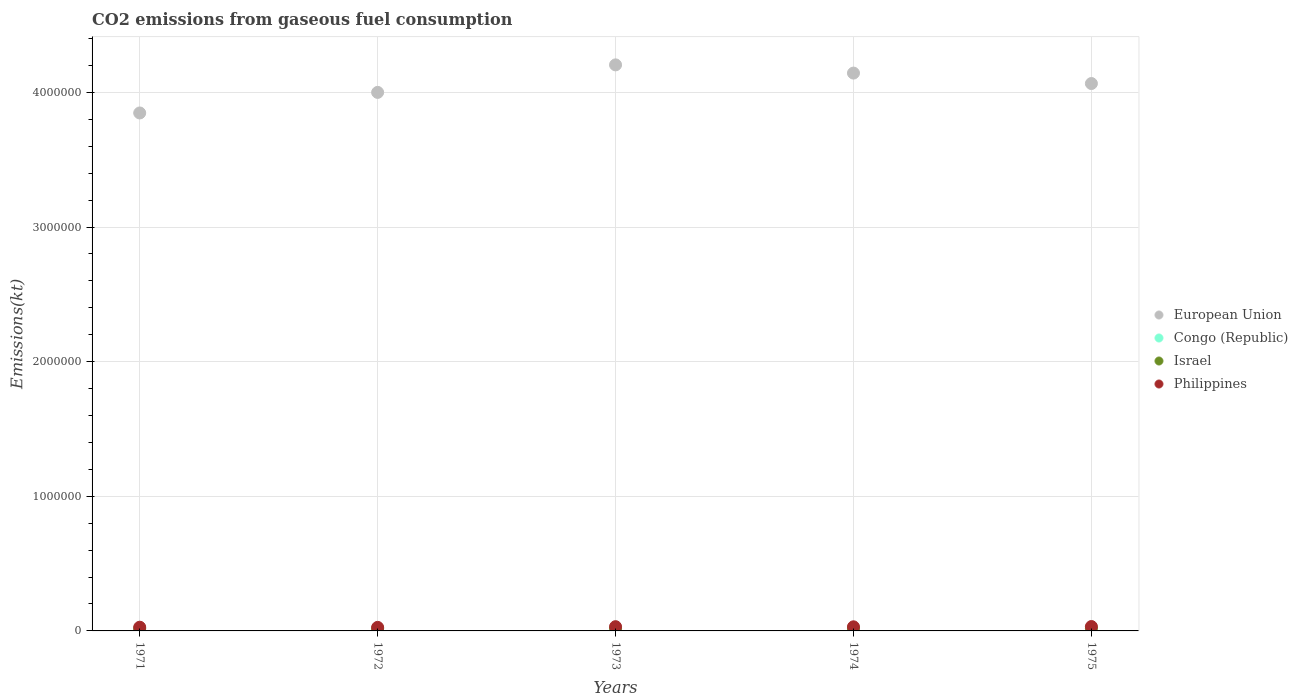Is the number of dotlines equal to the number of legend labels?
Your answer should be compact. Yes. What is the amount of CO2 emitted in Israel in 1974?
Your answer should be compact. 1.94e+04. Across all years, what is the maximum amount of CO2 emitted in European Union?
Offer a very short reply. 4.20e+06. Across all years, what is the minimum amount of CO2 emitted in European Union?
Ensure brevity in your answer.  3.85e+06. In which year was the amount of CO2 emitted in Congo (Republic) maximum?
Ensure brevity in your answer.  1974. In which year was the amount of CO2 emitted in European Union minimum?
Make the answer very short. 1971. What is the total amount of CO2 emitted in European Union in the graph?
Offer a very short reply. 2.03e+07. What is the difference between the amount of CO2 emitted in Philippines in 1972 and that in 1975?
Your response must be concise. -6083.55. What is the difference between the amount of CO2 emitted in Philippines in 1975 and the amount of CO2 emitted in Congo (Republic) in 1974?
Make the answer very short. 3.09e+04. What is the average amount of CO2 emitted in Israel per year?
Give a very brief answer. 1.83e+04. In the year 1974, what is the difference between the amount of CO2 emitted in Israel and amount of CO2 emitted in Congo (Republic)?
Your answer should be compact. 1.78e+04. What is the ratio of the amount of CO2 emitted in European Union in 1971 to that in 1974?
Offer a terse response. 0.93. What is the difference between the highest and the second highest amount of CO2 emitted in Israel?
Keep it short and to the point. 201.69. What is the difference between the highest and the lowest amount of CO2 emitted in Israel?
Your answer should be compact. 3399.31. In how many years, is the amount of CO2 emitted in European Union greater than the average amount of CO2 emitted in European Union taken over all years?
Keep it short and to the point. 3. Is the sum of the amount of CO2 emitted in Philippines in 1972 and 1974 greater than the maximum amount of CO2 emitted in Israel across all years?
Your response must be concise. Yes. Is it the case that in every year, the sum of the amount of CO2 emitted in Philippines and amount of CO2 emitted in Congo (Republic)  is greater than the sum of amount of CO2 emitted in European Union and amount of CO2 emitted in Israel?
Ensure brevity in your answer.  Yes. Is it the case that in every year, the sum of the amount of CO2 emitted in European Union and amount of CO2 emitted in Congo (Republic)  is greater than the amount of CO2 emitted in Israel?
Provide a succinct answer. Yes. Is the amount of CO2 emitted in Philippines strictly greater than the amount of CO2 emitted in Israel over the years?
Provide a short and direct response. Yes. Does the graph contain any zero values?
Ensure brevity in your answer.  No. Does the graph contain grids?
Give a very brief answer. Yes. How many legend labels are there?
Offer a very short reply. 4. How are the legend labels stacked?
Make the answer very short. Vertical. What is the title of the graph?
Offer a terse response. CO2 emissions from gaseous fuel consumption. Does "Virgin Islands" appear as one of the legend labels in the graph?
Offer a terse response. No. What is the label or title of the X-axis?
Keep it short and to the point. Years. What is the label or title of the Y-axis?
Your answer should be compact. Emissions(kt). What is the Emissions(kt) in European Union in 1971?
Provide a succinct answer. 3.85e+06. What is the Emissions(kt) in Congo (Republic) in 1971?
Provide a short and direct response. 685.73. What is the Emissions(kt) of Israel in 1971?
Offer a terse response. 1.62e+04. What is the Emissions(kt) of Philippines in 1971?
Offer a terse response. 2.76e+04. What is the Emissions(kt) of European Union in 1972?
Make the answer very short. 4.00e+06. What is the Emissions(kt) of Congo (Republic) in 1972?
Offer a terse response. 663.73. What is the Emissions(kt) in Israel in 1972?
Your answer should be very brief. 1.69e+04. What is the Emissions(kt) in Philippines in 1972?
Keep it short and to the point. 2.64e+04. What is the Emissions(kt) of European Union in 1973?
Your answer should be very brief. 4.20e+06. What is the Emissions(kt) in Congo (Republic) in 1973?
Ensure brevity in your answer.  1221.11. What is the Emissions(kt) in Israel in 1973?
Offer a very short reply. 1.93e+04. What is the Emissions(kt) in Philippines in 1973?
Make the answer very short. 3.15e+04. What is the Emissions(kt) of European Union in 1974?
Give a very brief answer. 4.14e+06. What is the Emissions(kt) in Congo (Republic) in 1974?
Provide a short and direct response. 1624.48. What is the Emissions(kt) in Israel in 1974?
Offer a terse response. 1.94e+04. What is the Emissions(kt) in Philippines in 1974?
Ensure brevity in your answer.  3.05e+04. What is the Emissions(kt) of European Union in 1975?
Your answer should be compact. 4.07e+06. What is the Emissions(kt) in Congo (Republic) in 1975?
Your response must be concise. 1100.1. What is the Emissions(kt) in Israel in 1975?
Give a very brief answer. 1.96e+04. What is the Emissions(kt) of Philippines in 1975?
Make the answer very short. 3.25e+04. Across all years, what is the maximum Emissions(kt) of European Union?
Make the answer very short. 4.20e+06. Across all years, what is the maximum Emissions(kt) of Congo (Republic)?
Give a very brief answer. 1624.48. Across all years, what is the maximum Emissions(kt) in Israel?
Give a very brief answer. 1.96e+04. Across all years, what is the maximum Emissions(kt) in Philippines?
Your answer should be compact. 3.25e+04. Across all years, what is the minimum Emissions(kt) of European Union?
Provide a succinct answer. 3.85e+06. Across all years, what is the minimum Emissions(kt) in Congo (Republic)?
Your answer should be compact. 663.73. Across all years, what is the minimum Emissions(kt) in Israel?
Your response must be concise. 1.62e+04. Across all years, what is the minimum Emissions(kt) in Philippines?
Your answer should be very brief. 2.64e+04. What is the total Emissions(kt) of European Union in the graph?
Provide a short and direct response. 2.03e+07. What is the total Emissions(kt) of Congo (Republic) in the graph?
Your answer should be compact. 5295.15. What is the total Emissions(kt) in Israel in the graph?
Keep it short and to the point. 9.16e+04. What is the total Emissions(kt) in Philippines in the graph?
Offer a very short reply. 1.49e+05. What is the difference between the Emissions(kt) in European Union in 1971 and that in 1972?
Provide a short and direct response. -1.53e+05. What is the difference between the Emissions(kt) of Congo (Republic) in 1971 and that in 1972?
Offer a very short reply. 22. What is the difference between the Emissions(kt) of Israel in 1971 and that in 1972?
Your response must be concise. -685.73. What is the difference between the Emissions(kt) in Philippines in 1971 and that in 1972?
Offer a terse response. 1144.1. What is the difference between the Emissions(kt) in European Union in 1971 and that in 1973?
Your answer should be very brief. -3.57e+05. What is the difference between the Emissions(kt) in Congo (Republic) in 1971 and that in 1973?
Make the answer very short. -535.38. What is the difference between the Emissions(kt) of Israel in 1971 and that in 1973?
Provide a short and direct response. -3061.95. What is the difference between the Emissions(kt) of Philippines in 1971 and that in 1973?
Provide a short and direct response. -3956.69. What is the difference between the Emissions(kt) in European Union in 1971 and that in 1974?
Your answer should be very brief. -2.96e+05. What is the difference between the Emissions(kt) of Congo (Republic) in 1971 and that in 1974?
Provide a succinct answer. -938.75. What is the difference between the Emissions(kt) in Israel in 1971 and that in 1974?
Your answer should be very brief. -3197.62. What is the difference between the Emissions(kt) in Philippines in 1971 and that in 1974?
Keep it short and to the point. -2944.6. What is the difference between the Emissions(kt) of European Union in 1971 and that in 1975?
Provide a short and direct response. -2.19e+05. What is the difference between the Emissions(kt) of Congo (Republic) in 1971 and that in 1975?
Your answer should be compact. -414.37. What is the difference between the Emissions(kt) in Israel in 1971 and that in 1975?
Your response must be concise. -3399.31. What is the difference between the Emissions(kt) of Philippines in 1971 and that in 1975?
Provide a short and direct response. -4939.45. What is the difference between the Emissions(kt) of European Union in 1972 and that in 1973?
Your answer should be compact. -2.04e+05. What is the difference between the Emissions(kt) in Congo (Republic) in 1972 and that in 1973?
Keep it short and to the point. -557.38. What is the difference between the Emissions(kt) of Israel in 1972 and that in 1973?
Give a very brief answer. -2376.22. What is the difference between the Emissions(kt) of Philippines in 1972 and that in 1973?
Your answer should be very brief. -5100.8. What is the difference between the Emissions(kt) of European Union in 1972 and that in 1974?
Provide a succinct answer. -1.43e+05. What is the difference between the Emissions(kt) of Congo (Republic) in 1972 and that in 1974?
Make the answer very short. -960.75. What is the difference between the Emissions(kt) of Israel in 1972 and that in 1974?
Ensure brevity in your answer.  -2511.89. What is the difference between the Emissions(kt) of Philippines in 1972 and that in 1974?
Provide a short and direct response. -4088.7. What is the difference between the Emissions(kt) in European Union in 1972 and that in 1975?
Make the answer very short. -6.58e+04. What is the difference between the Emissions(kt) of Congo (Republic) in 1972 and that in 1975?
Keep it short and to the point. -436.37. What is the difference between the Emissions(kt) of Israel in 1972 and that in 1975?
Offer a very short reply. -2713.58. What is the difference between the Emissions(kt) in Philippines in 1972 and that in 1975?
Your answer should be compact. -6083.55. What is the difference between the Emissions(kt) in European Union in 1973 and that in 1974?
Your response must be concise. 6.10e+04. What is the difference between the Emissions(kt) in Congo (Republic) in 1973 and that in 1974?
Your answer should be very brief. -403.37. What is the difference between the Emissions(kt) of Israel in 1973 and that in 1974?
Ensure brevity in your answer.  -135.68. What is the difference between the Emissions(kt) of Philippines in 1973 and that in 1974?
Your response must be concise. 1012.09. What is the difference between the Emissions(kt) of European Union in 1973 and that in 1975?
Your answer should be compact. 1.39e+05. What is the difference between the Emissions(kt) in Congo (Republic) in 1973 and that in 1975?
Provide a short and direct response. 121.01. What is the difference between the Emissions(kt) of Israel in 1973 and that in 1975?
Make the answer very short. -337.36. What is the difference between the Emissions(kt) of Philippines in 1973 and that in 1975?
Offer a very short reply. -982.76. What is the difference between the Emissions(kt) in European Union in 1974 and that in 1975?
Keep it short and to the point. 7.76e+04. What is the difference between the Emissions(kt) in Congo (Republic) in 1974 and that in 1975?
Ensure brevity in your answer.  524.38. What is the difference between the Emissions(kt) of Israel in 1974 and that in 1975?
Your answer should be compact. -201.69. What is the difference between the Emissions(kt) of Philippines in 1974 and that in 1975?
Give a very brief answer. -1994.85. What is the difference between the Emissions(kt) in European Union in 1971 and the Emissions(kt) in Congo (Republic) in 1972?
Offer a terse response. 3.85e+06. What is the difference between the Emissions(kt) in European Union in 1971 and the Emissions(kt) in Israel in 1972?
Make the answer very short. 3.83e+06. What is the difference between the Emissions(kt) in European Union in 1971 and the Emissions(kt) in Philippines in 1972?
Provide a short and direct response. 3.82e+06. What is the difference between the Emissions(kt) in Congo (Republic) in 1971 and the Emissions(kt) in Israel in 1972?
Keep it short and to the point. -1.62e+04. What is the difference between the Emissions(kt) of Congo (Republic) in 1971 and the Emissions(kt) of Philippines in 1972?
Provide a short and direct response. -2.58e+04. What is the difference between the Emissions(kt) of Israel in 1971 and the Emissions(kt) of Philippines in 1972?
Give a very brief answer. -1.02e+04. What is the difference between the Emissions(kt) in European Union in 1971 and the Emissions(kt) in Congo (Republic) in 1973?
Your response must be concise. 3.85e+06. What is the difference between the Emissions(kt) of European Union in 1971 and the Emissions(kt) of Israel in 1973?
Make the answer very short. 3.83e+06. What is the difference between the Emissions(kt) of European Union in 1971 and the Emissions(kt) of Philippines in 1973?
Ensure brevity in your answer.  3.82e+06. What is the difference between the Emissions(kt) of Congo (Republic) in 1971 and the Emissions(kt) of Israel in 1973?
Provide a succinct answer. -1.86e+04. What is the difference between the Emissions(kt) of Congo (Republic) in 1971 and the Emissions(kt) of Philippines in 1973?
Your answer should be very brief. -3.09e+04. What is the difference between the Emissions(kt) of Israel in 1971 and the Emissions(kt) of Philippines in 1973?
Provide a short and direct response. -1.53e+04. What is the difference between the Emissions(kt) in European Union in 1971 and the Emissions(kt) in Congo (Republic) in 1974?
Your answer should be compact. 3.85e+06. What is the difference between the Emissions(kt) in European Union in 1971 and the Emissions(kt) in Israel in 1974?
Your answer should be very brief. 3.83e+06. What is the difference between the Emissions(kt) in European Union in 1971 and the Emissions(kt) in Philippines in 1974?
Your response must be concise. 3.82e+06. What is the difference between the Emissions(kt) of Congo (Republic) in 1971 and the Emissions(kt) of Israel in 1974?
Make the answer very short. -1.88e+04. What is the difference between the Emissions(kt) in Congo (Republic) in 1971 and the Emissions(kt) in Philippines in 1974?
Provide a short and direct response. -2.98e+04. What is the difference between the Emissions(kt) in Israel in 1971 and the Emissions(kt) in Philippines in 1974?
Keep it short and to the point. -1.43e+04. What is the difference between the Emissions(kt) in European Union in 1971 and the Emissions(kt) in Congo (Republic) in 1975?
Offer a very short reply. 3.85e+06. What is the difference between the Emissions(kt) of European Union in 1971 and the Emissions(kt) of Israel in 1975?
Ensure brevity in your answer.  3.83e+06. What is the difference between the Emissions(kt) in European Union in 1971 and the Emissions(kt) in Philippines in 1975?
Your response must be concise. 3.81e+06. What is the difference between the Emissions(kt) of Congo (Republic) in 1971 and the Emissions(kt) of Israel in 1975?
Your response must be concise. -1.90e+04. What is the difference between the Emissions(kt) of Congo (Republic) in 1971 and the Emissions(kt) of Philippines in 1975?
Your answer should be compact. -3.18e+04. What is the difference between the Emissions(kt) in Israel in 1971 and the Emissions(kt) in Philippines in 1975?
Your response must be concise. -1.63e+04. What is the difference between the Emissions(kt) of European Union in 1972 and the Emissions(kt) of Congo (Republic) in 1973?
Provide a short and direct response. 4.00e+06. What is the difference between the Emissions(kt) of European Union in 1972 and the Emissions(kt) of Israel in 1973?
Your answer should be compact. 3.98e+06. What is the difference between the Emissions(kt) in European Union in 1972 and the Emissions(kt) in Philippines in 1973?
Make the answer very short. 3.97e+06. What is the difference between the Emissions(kt) in Congo (Republic) in 1972 and the Emissions(kt) in Israel in 1973?
Provide a short and direct response. -1.86e+04. What is the difference between the Emissions(kt) in Congo (Republic) in 1972 and the Emissions(kt) in Philippines in 1973?
Ensure brevity in your answer.  -3.09e+04. What is the difference between the Emissions(kt) of Israel in 1972 and the Emissions(kt) of Philippines in 1973?
Offer a terse response. -1.46e+04. What is the difference between the Emissions(kt) in European Union in 1972 and the Emissions(kt) in Congo (Republic) in 1974?
Offer a terse response. 4.00e+06. What is the difference between the Emissions(kt) in European Union in 1972 and the Emissions(kt) in Israel in 1974?
Keep it short and to the point. 3.98e+06. What is the difference between the Emissions(kt) in European Union in 1972 and the Emissions(kt) in Philippines in 1974?
Provide a succinct answer. 3.97e+06. What is the difference between the Emissions(kt) in Congo (Republic) in 1972 and the Emissions(kt) in Israel in 1974?
Offer a terse response. -1.88e+04. What is the difference between the Emissions(kt) of Congo (Republic) in 1972 and the Emissions(kt) of Philippines in 1974?
Make the answer very short. -2.99e+04. What is the difference between the Emissions(kt) in Israel in 1972 and the Emissions(kt) in Philippines in 1974?
Your response must be concise. -1.36e+04. What is the difference between the Emissions(kt) of European Union in 1972 and the Emissions(kt) of Congo (Republic) in 1975?
Offer a terse response. 4.00e+06. What is the difference between the Emissions(kt) in European Union in 1972 and the Emissions(kt) in Israel in 1975?
Provide a short and direct response. 3.98e+06. What is the difference between the Emissions(kt) in European Union in 1972 and the Emissions(kt) in Philippines in 1975?
Provide a short and direct response. 3.97e+06. What is the difference between the Emissions(kt) of Congo (Republic) in 1972 and the Emissions(kt) of Israel in 1975?
Your response must be concise. -1.90e+04. What is the difference between the Emissions(kt) of Congo (Republic) in 1972 and the Emissions(kt) of Philippines in 1975?
Make the answer very short. -3.19e+04. What is the difference between the Emissions(kt) in Israel in 1972 and the Emissions(kt) in Philippines in 1975?
Offer a terse response. -1.56e+04. What is the difference between the Emissions(kt) in European Union in 1973 and the Emissions(kt) in Congo (Republic) in 1974?
Keep it short and to the point. 4.20e+06. What is the difference between the Emissions(kt) of European Union in 1973 and the Emissions(kt) of Israel in 1974?
Your answer should be very brief. 4.18e+06. What is the difference between the Emissions(kt) in European Union in 1973 and the Emissions(kt) in Philippines in 1974?
Your answer should be very brief. 4.17e+06. What is the difference between the Emissions(kt) in Congo (Republic) in 1973 and the Emissions(kt) in Israel in 1974?
Provide a succinct answer. -1.82e+04. What is the difference between the Emissions(kt) in Congo (Republic) in 1973 and the Emissions(kt) in Philippines in 1974?
Provide a succinct answer. -2.93e+04. What is the difference between the Emissions(kt) of Israel in 1973 and the Emissions(kt) of Philippines in 1974?
Your answer should be compact. -1.12e+04. What is the difference between the Emissions(kt) in European Union in 1973 and the Emissions(kt) in Congo (Republic) in 1975?
Your response must be concise. 4.20e+06. What is the difference between the Emissions(kt) of European Union in 1973 and the Emissions(kt) of Israel in 1975?
Offer a very short reply. 4.18e+06. What is the difference between the Emissions(kt) in European Union in 1973 and the Emissions(kt) in Philippines in 1975?
Give a very brief answer. 4.17e+06. What is the difference between the Emissions(kt) in Congo (Republic) in 1973 and the Emissions(kt) in Israel in 1975?
Your answer should be very brief. -1.84e+04. What is the difference between the Emissions(kt) of Congo (Republic) in 1973 and the Emissions(kt) of Philippines in 1975?
Keep it short and to the point. -3.13e+04. What is the difference between the Emissions(kt) in Israel in 1973 and the Emissions(kt) in Philippines in 1975?
Your answer should be compact. -1.32e+04. What is the difference between the Emissions(kt) of European Union in 1974 and the Emissions(kt) of Congo (Republic) in 1975?
Offer a terse response. 4.14e+06. What is the difference between the Emissions(kt) of European Union in 1974 and the Emissions(kt) of Israel in 1975?
Offer a terse response. 4.12e+06. What is the difference between the Emissions(kt) in European Union in 1974 and the Emissions(kt) in Philippines in 1975?
Offer a terse response. 4.11e+06. What is the difference between the Emissions(kt) in Congo (Republic) in 1974 and the Emissions(kt) in Israel in 1975?
Ensure brevity in your answer.  -1.80e+04. What is the difference between the Emissions(kt) in Congo (Republic) in 1974 and the Emissions(kt) in Philippines in 1975?
Make the answer very short. -3.09e+04. What is the difference between the Emissions(kt) of Israel in 1974 and the Emissions(kt) of Philippines in 1975?
Provide a succinct answer. -1.31e+04. What is the average Emissions(kt) of European Union per year?
Make the answer very short. 4.05e+06. What is the average Emissions(kt) of Congo (Republic) per year?
Offer a terse response. 1059.03. What is the average Emissions(kt) in Israel per year?
Your response must be concise. 1.83e+04. What is the average Emissions(kt) of Philippines per year?
Your answer should be very brief. 2.97e+04. In the year 1971, what is the difference between the Emissions(kt) in European Union and Emissions(kt) in Congo (Republic)?
Offer a very short reply. 3.85e+06. In the year 1971, what is the difference between the Emissions(kt) in European Union and Emissions(kt) in Israel?
Make the answer very short. 3.83e+06. In the year 1971, what is the difference between the Emissions(kt) in European Union and Emissions(kt) in Philippines?
Make the answer very short. 3.82e+06. In the year 1971, what is the difference between the Emissions(kt) in Congo (Republic) and Emissions(kt) in Israel?
Keep it short and to the point. -1.56e+04. In the year 1971, what is the difference between the Emissions(kt) in Congo (Republic) and Emissions(kt) in Philippines?
Provide a short and direct response. -2.69e+04. In the year 1971, what is the difference between the Emissions(kt) of Israel and Emissions(kt) of Philippines?
Your response must be concise. -1.13e+04. In the year 1972, what is the difference between the Emissions(kt) in European Union and Emissions(kt) in Congo (Republic)?
Your answer should be very brief. 4.00e+06. In the year 1972, what is the difference between the Emissions(kt) in European Union and Emissions(kt) in Israel?
Your answer should be very brief. 3.98e+06. In the year 1972, what is the difference between the Emissions(kt) in European Union and Emissions(kt) in Philippines?
Offer a terse response. 3.97e+06. In the year 1972, what is the difference between the Emissions(kt) in Congo (Republic) and Emissions(kt) in Israel?
Make the answer very short. -1.63e+04. In the year 1972, what is the difference between the Emissions(kt) in Congo (Republic) and Emissions(kt) in Philippines?
Offer a very short reply. -2.58e+04. In the year 1972, what is the difference between the Emissions(kt) of Israel and Emissions(kt) of Philippines?
Make the answer very short. -9508.53. In the year 1973, what is the difference between the Emissions(kt) of European Union and Emissions(kt) of Congo (Republic)?
Give a very brief answer. 4.20e+06. In the year 1973, what is the difference between the Emissions(kt) in European Union and Emissions(kt) in Israel?
Give a very brief answer. 4.19e+06. In the year 1973, what is the difference between the Emissions(kt) of European Union and Emissions(kt) of Philippines?
Your response must be concise. 4.17e+06. In the year 1973, what is the difference between the Emissions(kt) in Congo (Republic) and Emissions(kt) in Israel?
Provide a succinct answer. -1.81e+04. In the year 1973, what is the difference between the Emissions(kt) of Congo (Republic) and Emissions(kt) of Philippines?
Give a very brief answer. -3.03e+04. In the year 1973, what is the difference between the Emissions(kt) of Israel and Emissions(kt) of Philippines?
Offer a terse response. -1.22e+04. In the year 1974, what is the difference between the Emissions(kt) in European Union and Emissions(kt) in Congo (Republic)?
Offer a very short reply. 4.14e+06. In the year 1974, what is the difference between the Emissions(kt) of European Union and Emissions(kt) of Israel?
Offer a very short reply. 4.12e+06. In the year 1974, what is the difference between the Emissions(kt) of European Union and Emissions(kt) of Philippines?
Offer a very short reply. 4.11e+06. In the year 1974, what is the difference between the Emissions(kt) of Congo (Republic) and Emissions(kt) of Israel?
Your answer should be compact. -1.78e+04. In the year 1974, what is the difference between the Emissions(kt) in Congo (Republic) and Emissions(kt) in Philippines?
Give a very brief answer. -2.89e+04. In the year 1974, what is the difference between the Emissions(kt) in Israel and Emissions(kt) in Philippines?
Your answer should be compact. -1.11e+04. In the year 1975, what is the difference between the Emissions(kt) in European Union and Emissions(kt) in Congo (Republic)?
Your answer should be compact. 4.06e+06. In the year 1975, what is the difference between the Emissions(kt) of European Union and Emissions(kt) of Israel?
Give a very brief answer. 4.05e+06. In the year 1975, what is the difference between the Emissions(kt) in European Union and Emissions(kt) in Philippines?
Ensure brevity in your answer.  4.03e+06. In the year 1975, what is the difference between the Emissions(kt) in Congo (Republic) and Emissions(kt) in Israel?
Give a very brief answer. -1.85e+04. In the year 1975, what is the difference between the Emissions(kt) of Congo (Republic) and Emissions(kt) of Philippines?
Make the answer very short. -3.14e+04. In the year 1975, what is the difference between the Emissions(kt) in Israel and Emissions(kt) in Philippines?
Your answer should be compact. -1.29e+04. What is the ratio of the Emissions(kt) of European Union in 1971 to that in 1972?
Keep it short and to the point. 0.96. What is the ratio of the Emissions(kt) of Congo (Republic) in 1971 to that in 1972?
Your answer should be compact. 1.03. What is the ratio of the Emissions(kt) in Israel in 1971 to that in 1972?
Give a very brief answer. 0.96. What is the ratio of the Emissions(kt) of Philippines in 1971 to that in 1972?
Your answer should be compact. 1.04. What is the ratio of the Emissions(kt) of European Union in 1971 to that in 1973?
Offer a terse response. 0.92. What is the ratio of the Emissions(kt) of Congo (Republic) in 1971 to that in 1973?
Provide a succinct answer. 0.56. What is the ratio of the Emissions(kt) of Israel in 1971 to that in 1973?
Provide a succinct answer. 0.84. What is the ratio of the Emissions(kt) of Philippines in 1971 to that in 1973?
Give a very brief answer. 0.87. What is the ratio of the Emissions(kt) in European Union in 1971 to that in 1974?
Offer a terse response. 0.93. What is the ratio of the Emissions(kt) in Congo (Republic) in 1971 to that in 1974?
Your response must be concise. 0.42. What is the ratio of the Emissions(kt) of Israel in 1971 to that in 1974?
Offer a terse response. 0.84. What is the ratio of the Emissions(kt) of Philippines in 1971 to that in 1974?
Offer a terse response. 0.9. What is the ratio of the Emissions(kt) of European Union in 1971 to that in 1975?
Your answer should be compact. 0.95. What is the ratio of the Emissions(kt) of Congo (Republic) in 1971 to that in 1975?
Ensure brevity in your answer.  0.62. What is the ratio of the Emissions(kt) in Israel in 1971 to that in 1975?
Provide a short and direct response. 0.83. What is the ratio of the Emissions(kt) in Philippines in 1971 to that in 1975?
Provide a short and direct response. 0.85. What is the ratio of the Emissions(kt) of European Union in 1972 to that in 1973?
Your response must be concise. 0.95. What is the ratio of the Emissions(kt) in Congo (Republic) in 1972 to that in 1973?
Offer a very short reply. 0.54. What is the ratio of the Emissions(kt) of Israel in 1972 to that in 1973?
Give a very brief answer. 0.88. What is the ratio of the Emissions(kt) of Philippines in 1972 to that in 1973?
Make the answer very short. 0.84. What is the ratio of the Emissions(kt) of European Union in 1972 to that in 1974?
Provide a short and direct response. 0.97. What is the ratio of the Emissions(kt) of Congo (Republic) in 1972 to that in 1974?
Make the answer very short. 0.41. What is the ratio of the Emissions(kt) of Israel in 1972 to that in 1974?
Make the answer very short. 0.87. What is the ratio of the Emissions(kt) of Philippines in 1972 to that in 1974?
Keep it short and to the point. 0.87. What is the ratio of the Emissions(kt) in European Union in 1972 to that in 1975?
Ensure brevity in your answer.  0.98. What is the ratio of the Emissions(kt) of Congo (Republic) in 1972 to that in 1975?
Provide a short and direct response. 0.6. What is the ratio of the Emissions(kt) in Israel in 1972 to that in 1975?
Offer a terse response. 0.86. What is the ratio of the Emissions(kt) in Philippines in 1972 to that in 1975?
Keep it short and to the point. 0.81. What is the ratio of the Emissions(kt) in European Union in 1973 to that in 1974?
Your answer should be very brief. 1.01. What is the ratio of the Emissions(kt) in Congo (Republic) in 1973 to that in 1974?
Provide a short and direct response. 0.75. What is the ratio of the Emissions(kt) in Philippines in 1973 to that in 1974?
Your response must be concise. 1.03. What is the ratio of the Emissions(kt) of European Union in 1973 to that in 1975?
Your response must be concise. 1.03. What is the ratio of the Emissions(kt) in Congo (Republic) in 1973 to that in 1975?
Your answer should be compact. 1.11. What is the ratio of the Emissions(kt) of Israel in 1973 to that in 1975?
Your answer should be very brief. 0.98. What is the ratio of the Emissions(kt) in Philippines in 1973 to that in 1975?
Offer a very short reply. 0.97. What is the ratio of the Emissions(kt) of European Union in 1974 to that in 1975?
Offer a terse response. 1.02. What is the ratio of the Emissions(kt) of Congo (Republic) in 1974 to that in 1975?
Make the answer very short. 1.48. What is the ratio of the Emissions(kt) of Philippines in 1974 to that in 1975?
Your answer should be compact. 0.94. What is the difference between the highest and the second highest Emissions(kt) in European Union?
Your response must be concise. 6.10e+04. What is the difference between the highest and the second highest Emissions(kt) in Congo (Republic)?
Your response must be concise. 403.37. What is the difference between the highest and the second highest Emissions(kt) of Israel?
Provide a short and direct response. 201.69. What is the difference between the highest and the second highest Emissions(kt) in Philippines?
Give a very brief answer. 982.76. What is the difference between the highest and the lowest Emissions(kt) in European Union?
Provide a short and direct response. 3.57e+05. What is the difference between the highest and the lowest Emissions(kt) of Congo (Republic)?
Your response must be concise. 960.75. What is the difference between the highest and the lowest Emissions(kt) in Israel?
Offer a very short reply. 3399.31. What is the difference between the highest and the lowest Emissions(kt) of Philippines?
Offer a terse response. 6083.55. 